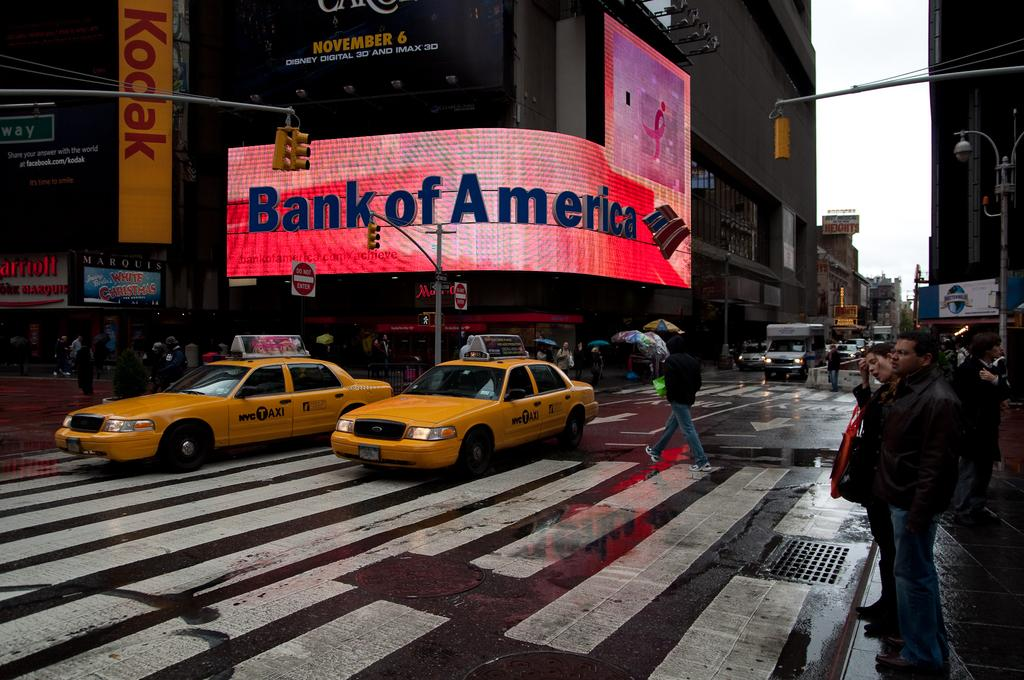Provide a one-sentence caption for the provided image. A curved, lighted, signboard in red with Bank of America in blue on a buy street. 